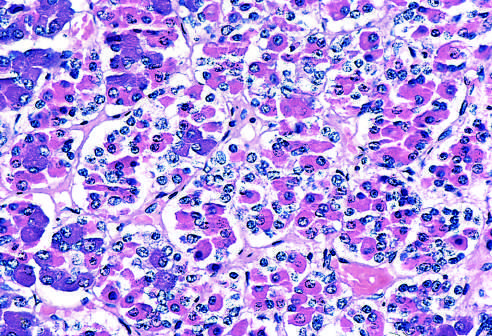what are colors of these hormones?
Answer the question using a single word or phrase. Basophilic (blue) 